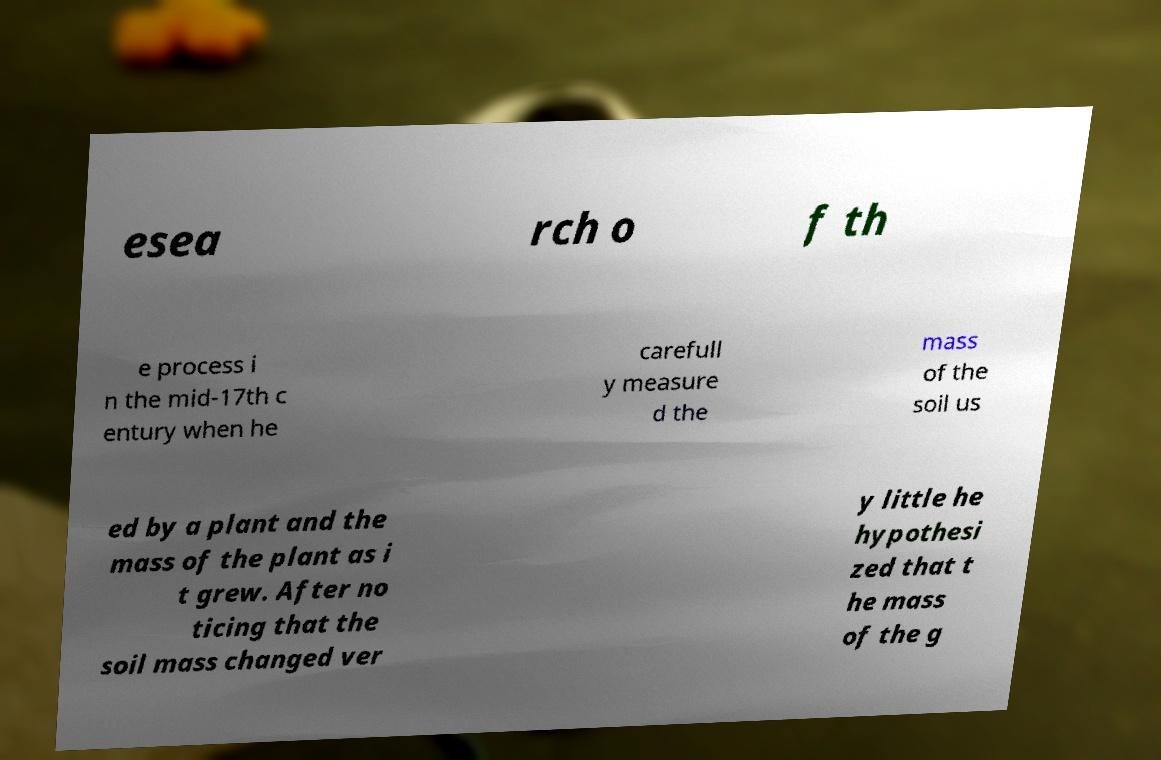For documentation purposes, I need the text within this image transcribed. Could you provide that? esea rch o f th e process i n the mid-17th c entury when he carefull y measure d the mass of the soil us ed by a plant and the mass of the plant as i t grew. After no ticing that the soil mass changed ver y little he hypothesi zed that t he mass of the g 